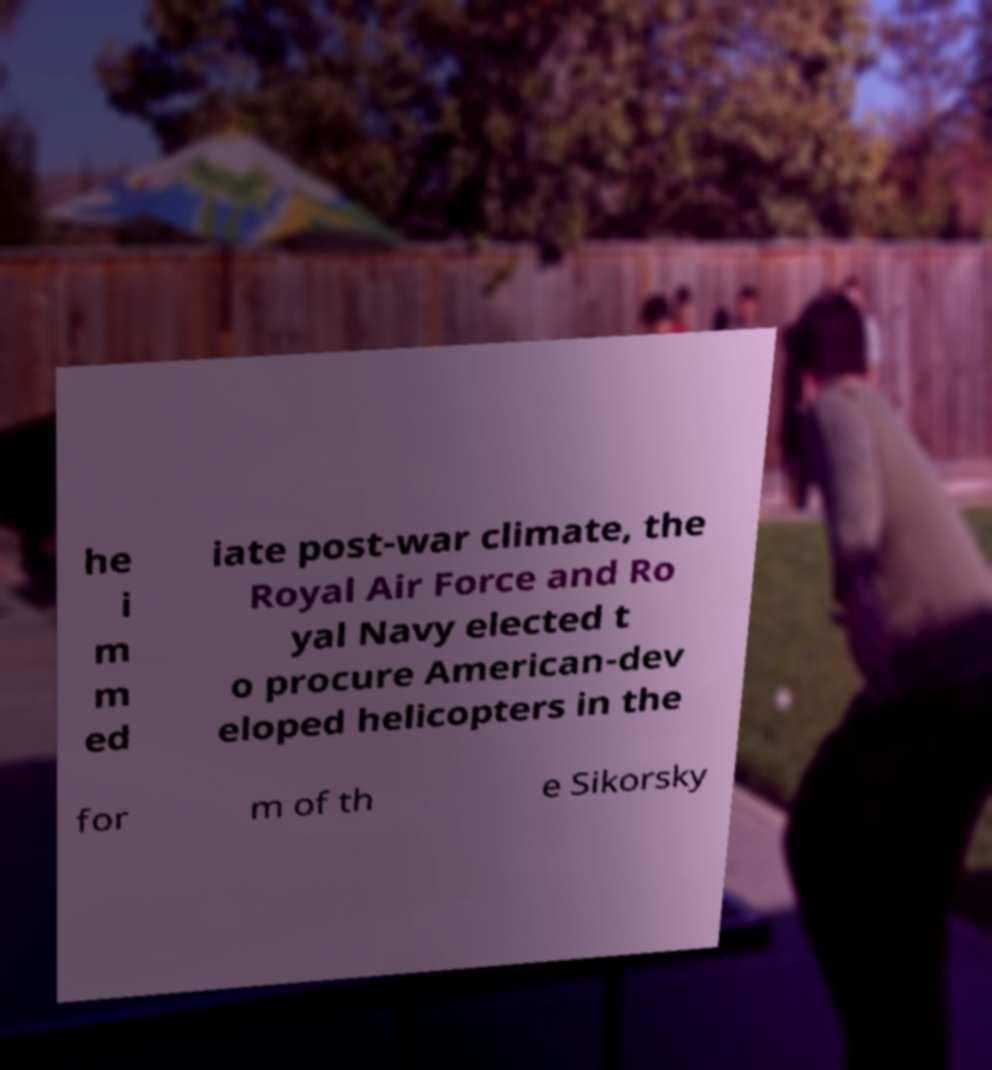Could you extract and type out the text from this image? he i m m ed iate post-war climate, the Royal Air Force and Ro yal Navy elected t o procure American-dev eloped helicopters in the for m of th e Sikorsky 